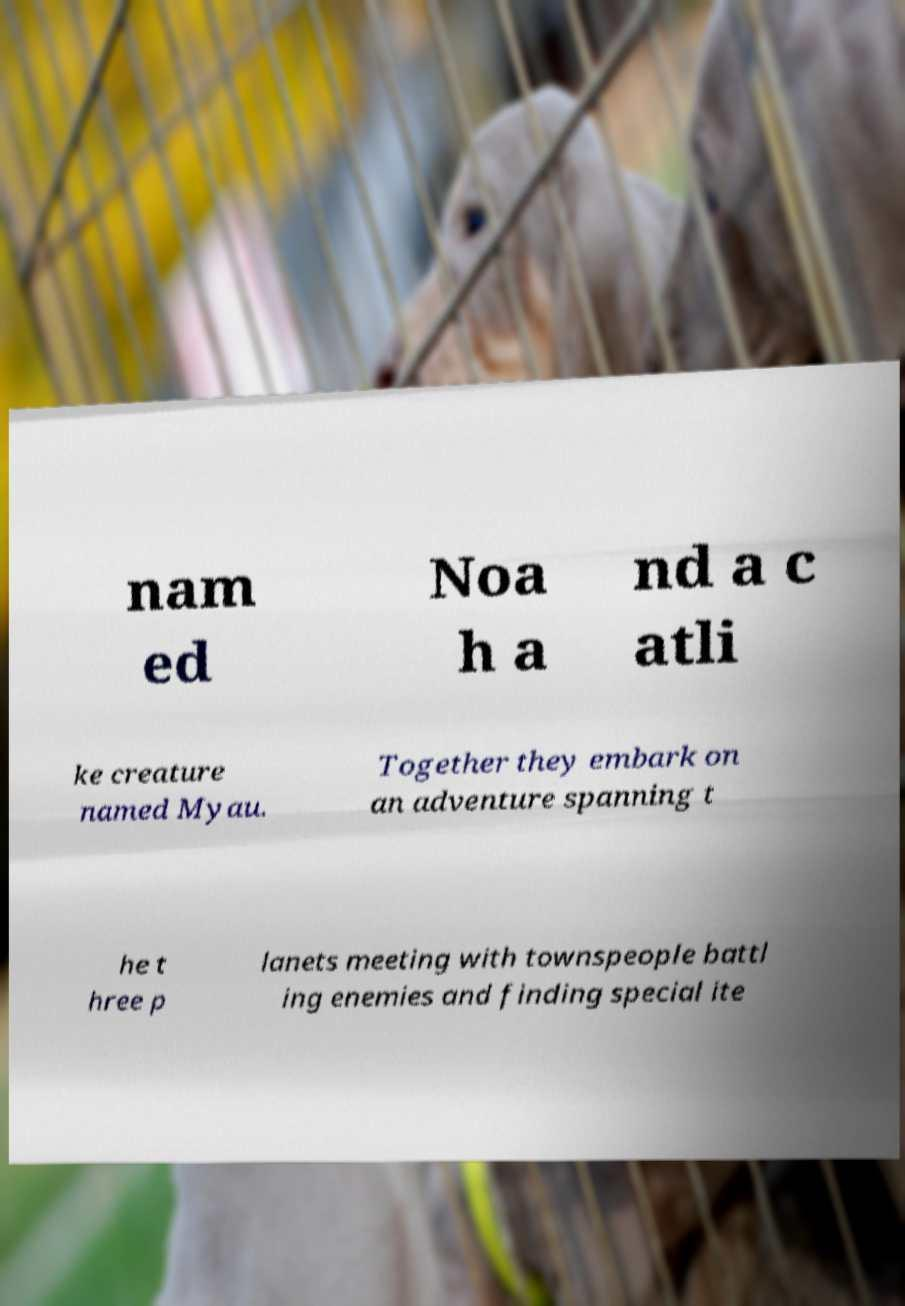Can you read and provide the text displayed in the image?This photo seems to have some interesting text. Can you extract and type it out for me? nam ed Noa h a nd a c atli ke creature named Myau. Together they embark on an adventure spanning t he t hree p lanets meeting with townspeople battl ing enemies and finding special ite 